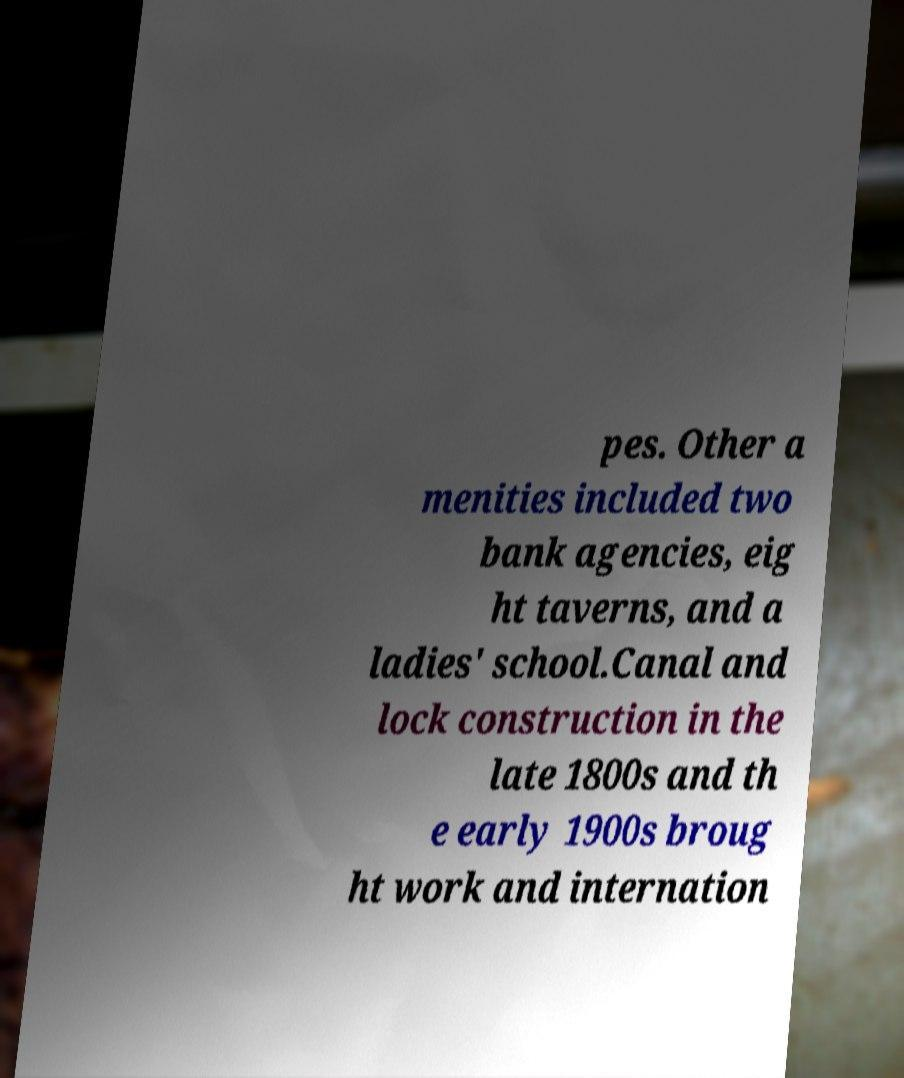What messages or text are displayed in this image? I need them in a readable, typed format. pes. Other a menities included two bank agencies, eig ht taverns, and a ladies' school.Canal and lock construction in the late 1800s and th e early 1900s broug ht work and internation 